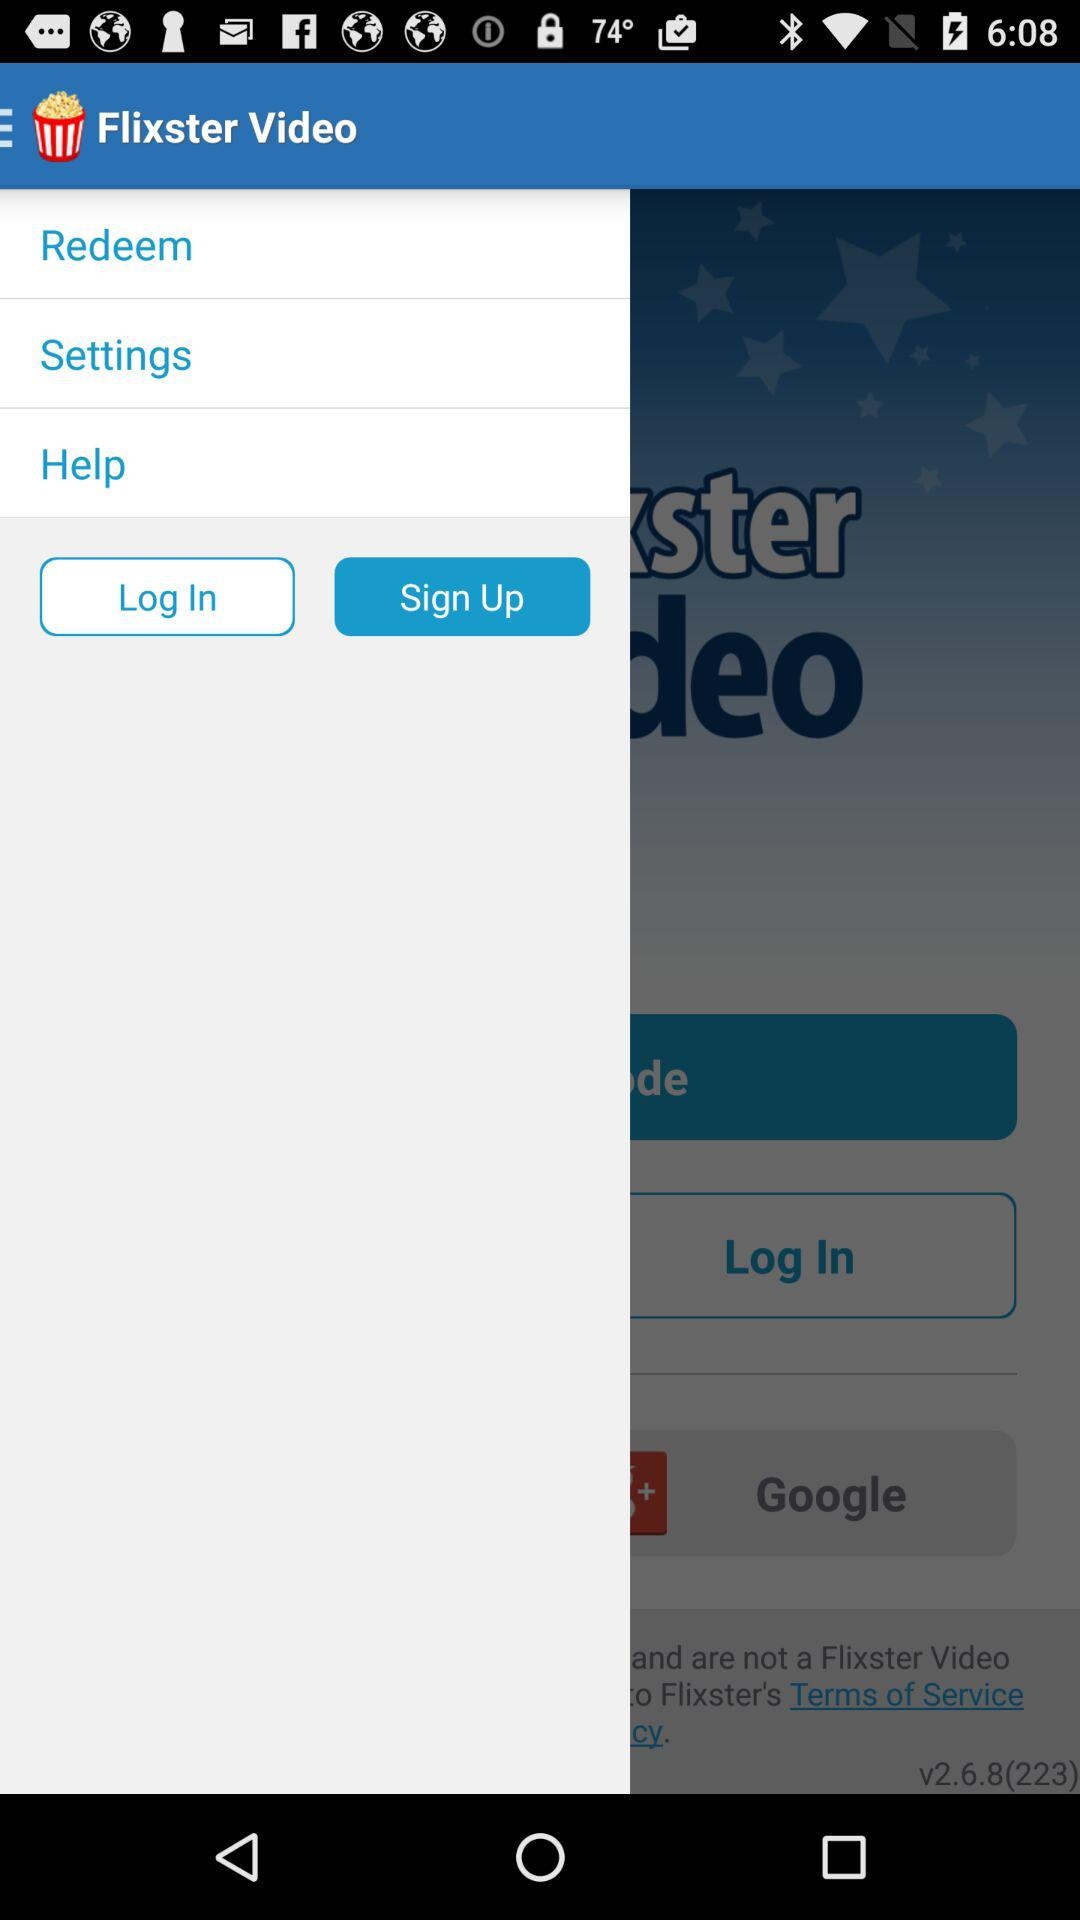What is the app name? The app name is "Flixster Video". 